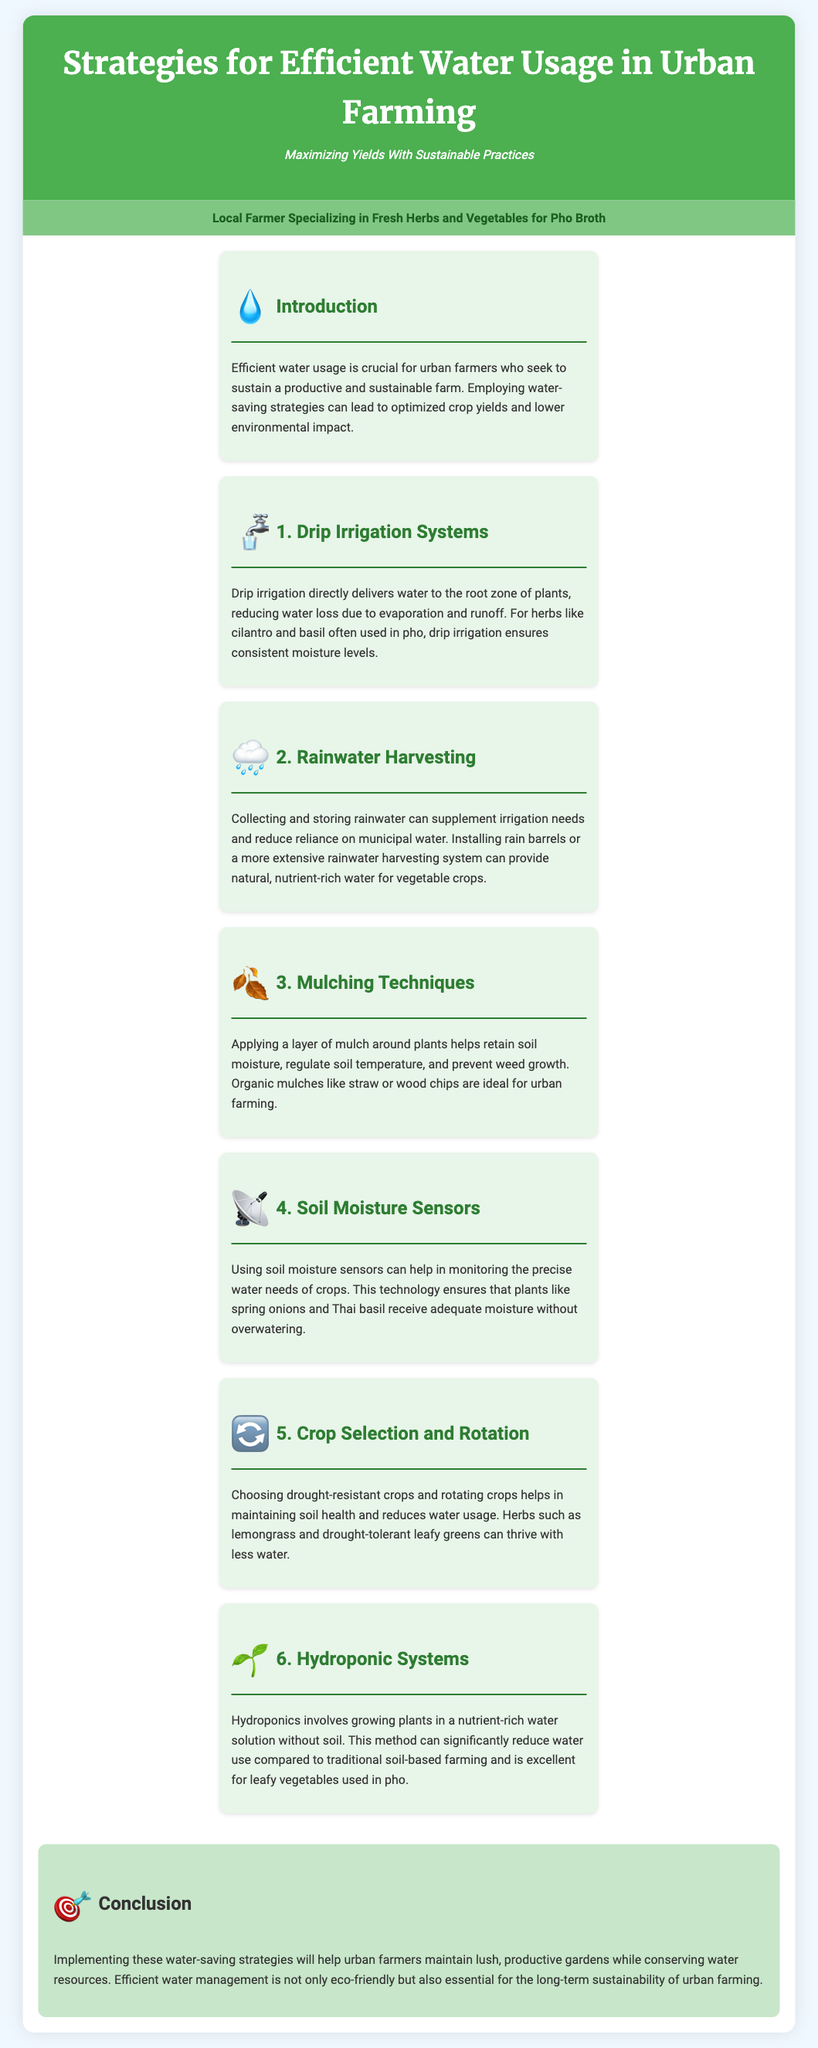What is the title of the infographic? The title appears at the top of the document and specifies the main topic addressed within it.
Answer: Strategies for Efficient Water Usage in Urban Farming What is the first strategy mentioned for water efficiency? The first strategy listed in the document describes a method of irrigation that minimizes water loss.
Answer: Drip Irrigation Systems What benefit does mulching provide? The section about mulching explains its advantages in maintaining soil quality and productivity.
Answer: Retain soil moisture What type of farming does hydroponics represent? This section describes a specific method of growing plants that does not use soil.
Answer: Soil-less farming What is one benefit of using soil moisture sensors? The document states that these sensors help determine the exact water requirements of crops.
Answer: Monitoring precise water needs How many strategies are mentioned in total? The document enumerates the different strategies, which can be counted to find the total.
Answer: Six What color is used for the background of the conclusion section? The background color of the conclusion section is highlighted in the styling provided in the document.
Answer: Light green What is the purpose of rainwater harvesting? The rainwater harvesting section outlines its role in reducing reliance on another water source.
Answer: Supplement irrigation needs Which crop is mentioned as drought-resistant? A specific crop is suggested as being able to grow with less water in the document.
Answer: Lemongrass 